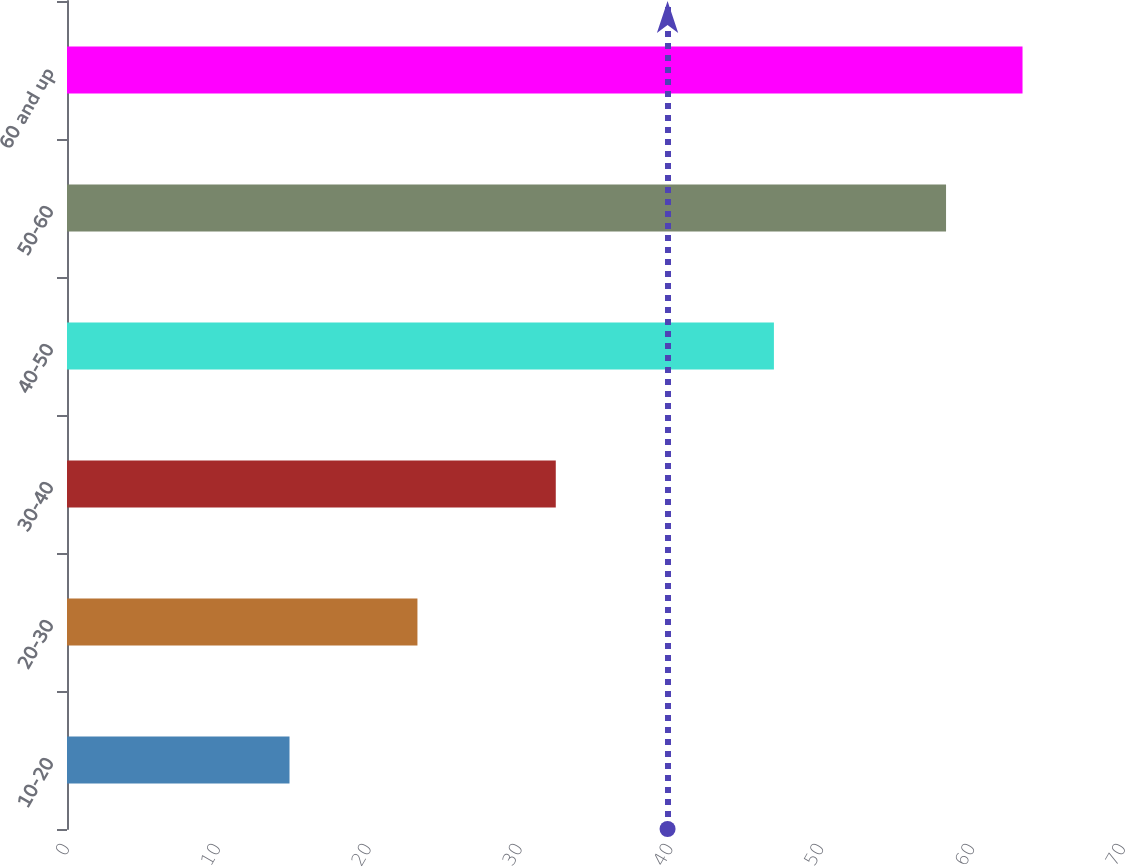<chart> <loc_0><loc_0><loc_500><loc_500><bar_chart><fcel>10-20<fcel>20-30<fcel>30-40<fcel>40-50<fcel>50-60<fcel>60 and up<nl><fcel>14.75<fcel>23.23<fcel>32.4<fcel>46.86<fcel>58.27<fcel>63.34<nl></chart> 